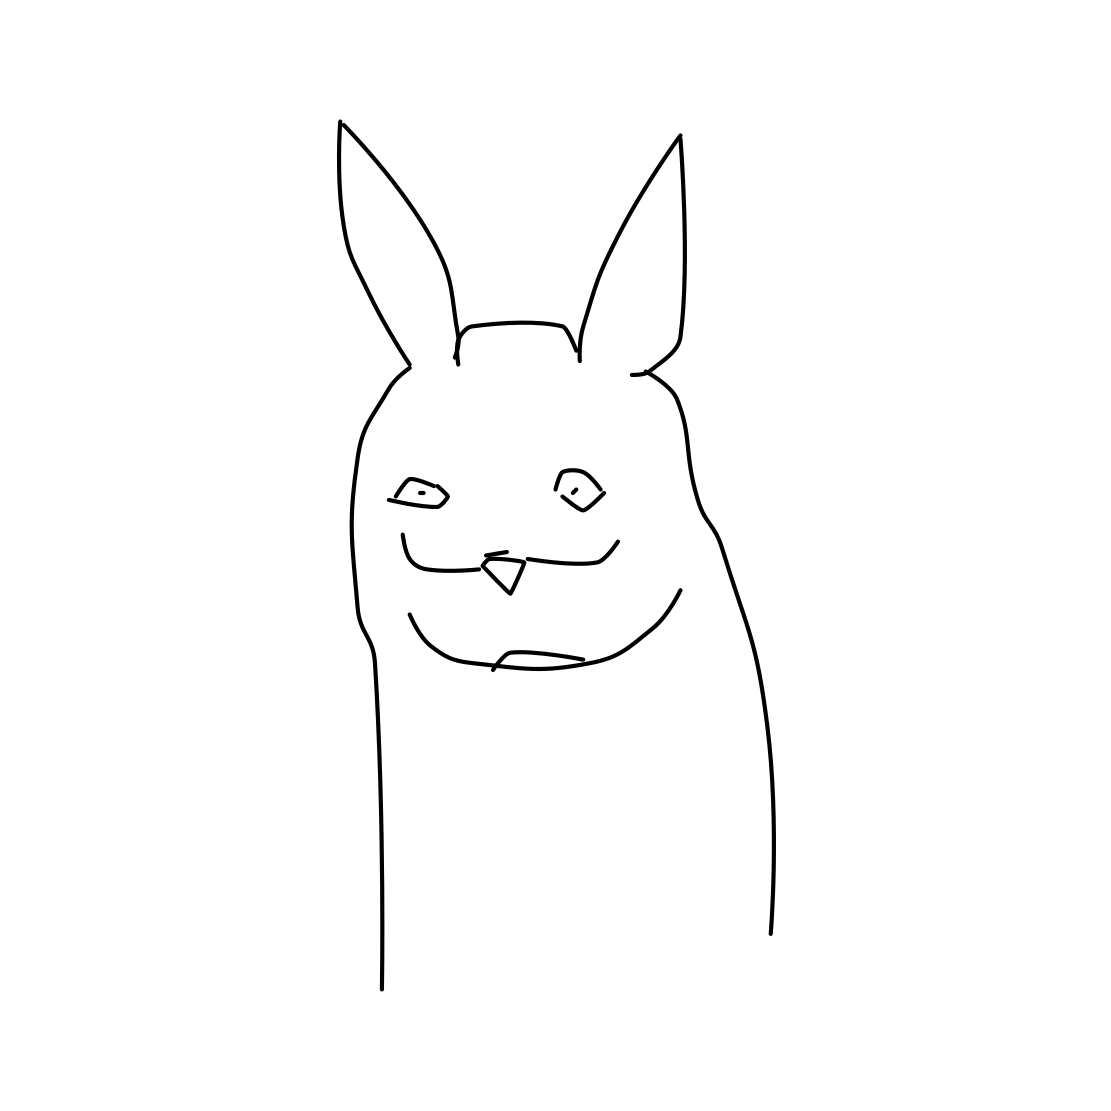How might this image be used creatively? This image could be used as inspiration for character design in a graphic novel, as an avatar in virtual communities, or even as a playful mascot for a brand aiming for a joyful, youthful image. 